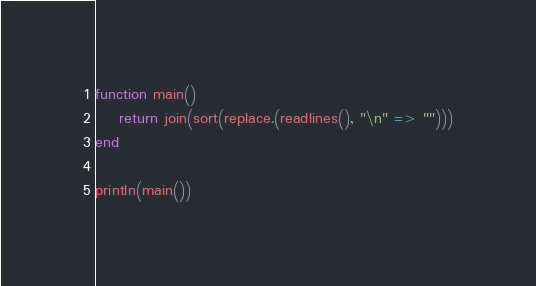Convert code to text. <code><loc_0><loc_0><loc_500><loc_500><_Julia_>function main()
    return join(sort(replace.(readlines(), "\n" => "")))
end

println(main())
</code> 